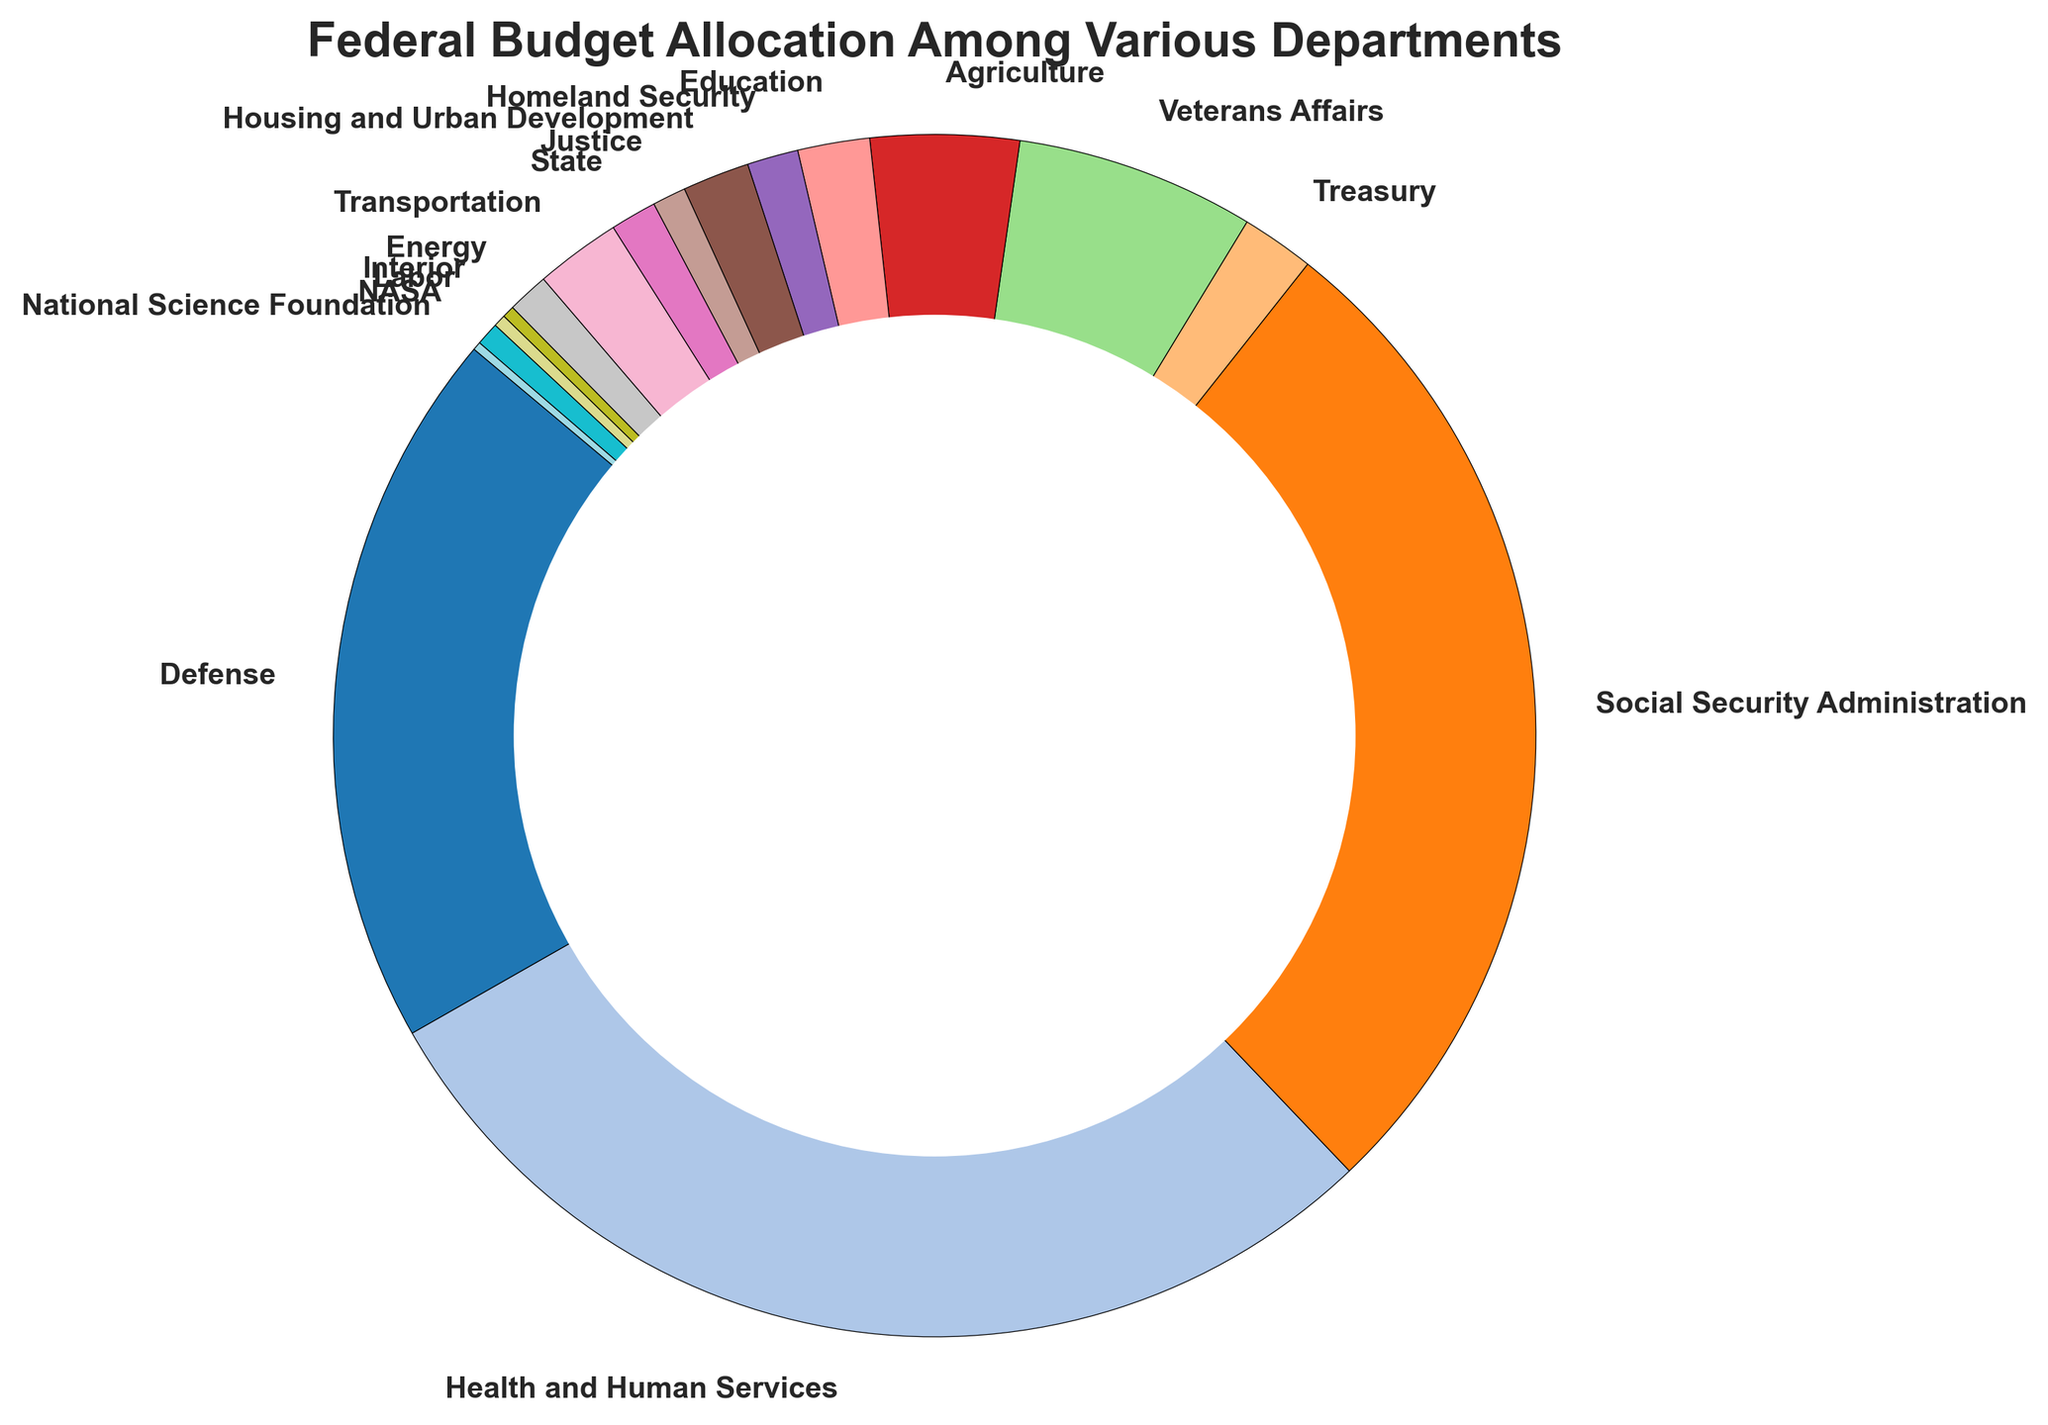Which department receives the largest allocation in the federal budget? By observing the size of the slices in the pie chart, the largest one represents Health and Human Services
Answer: Health and Human Services What is the difference in budget allocation between the Social Security Administration and the Defense department? The size of the slices shows that the Social Security Administration and the Defense department are significant. According to the labels, the Social Security Administration receives $1,030,000,000,000, and the Defense department receives $732,000,000,000. The difference is $1,030,000,000,000 - $732,000,000,000 = $298,000,000,000
Answer: $298,000,000,000 Which department has a larger budget allocation, Veterans Affairs or Education? By comparing the two slices visually, the slice for Veterans Affairs is larger than for Education
Answer: Veterans Affairs How does the budget allocation for Transportation compare to that of Treasury and Energy combined? From the chart, the allocation for Transportation is $87,000,000,000. Treasury is $74,100,000,000 and Energy is $42,000,000,000. Combined, Treasury and Energy receive $74,100,000,000 + $42,000,000,000 = $116,100,000,000, which is more than Transportation's $87,000,000,000
Answer: Treasury and Energy combined What is the total budget allocation for the departments: Justice, State, and Homeland Security? From the chart, the budget allocations are: Justice: $34,100,000,000, State: $47,000,000,000, Homeland Security: $52,000,000,000. Summing them up, $34,100,000,000 + $47,000,000,000 + $52,000,000,000 = $133,100,000,000
Answer: $133,100,000,000 Which department's budget is closest in size to NASA's? Visually comparing the slices, NASA’s slice is similar in size to the Interior department. NASA's allocation is $23,600,000,000 and the Interior's allocation is $12,300,000,000
Answer: Interior Between the Agriculture department and Housing and Urban Development, which has a higher federal budget allocation? By comparing the slices for Agriculture (larger) and Housing and Urban Development (smaller), it is clear that the Agriculture department has a higher allocation
Answer: Agriculture What percentage of the federal budget is allocated to the Defense department? The pie chart shows percentages alongside each department label. The Defense department allocation is labeled as 15.5%
Answer: 15.5% In terms of budget allocation, rank the Health and Human Services, Social Security Administration, and Defense from highest to lowest. By observing the sizes of the slices, Health and Human Services is the largest, followed by the Social Security Administration, and then the Defense department.
Answer: Health and Human Services, Social Security Administration, Defense 